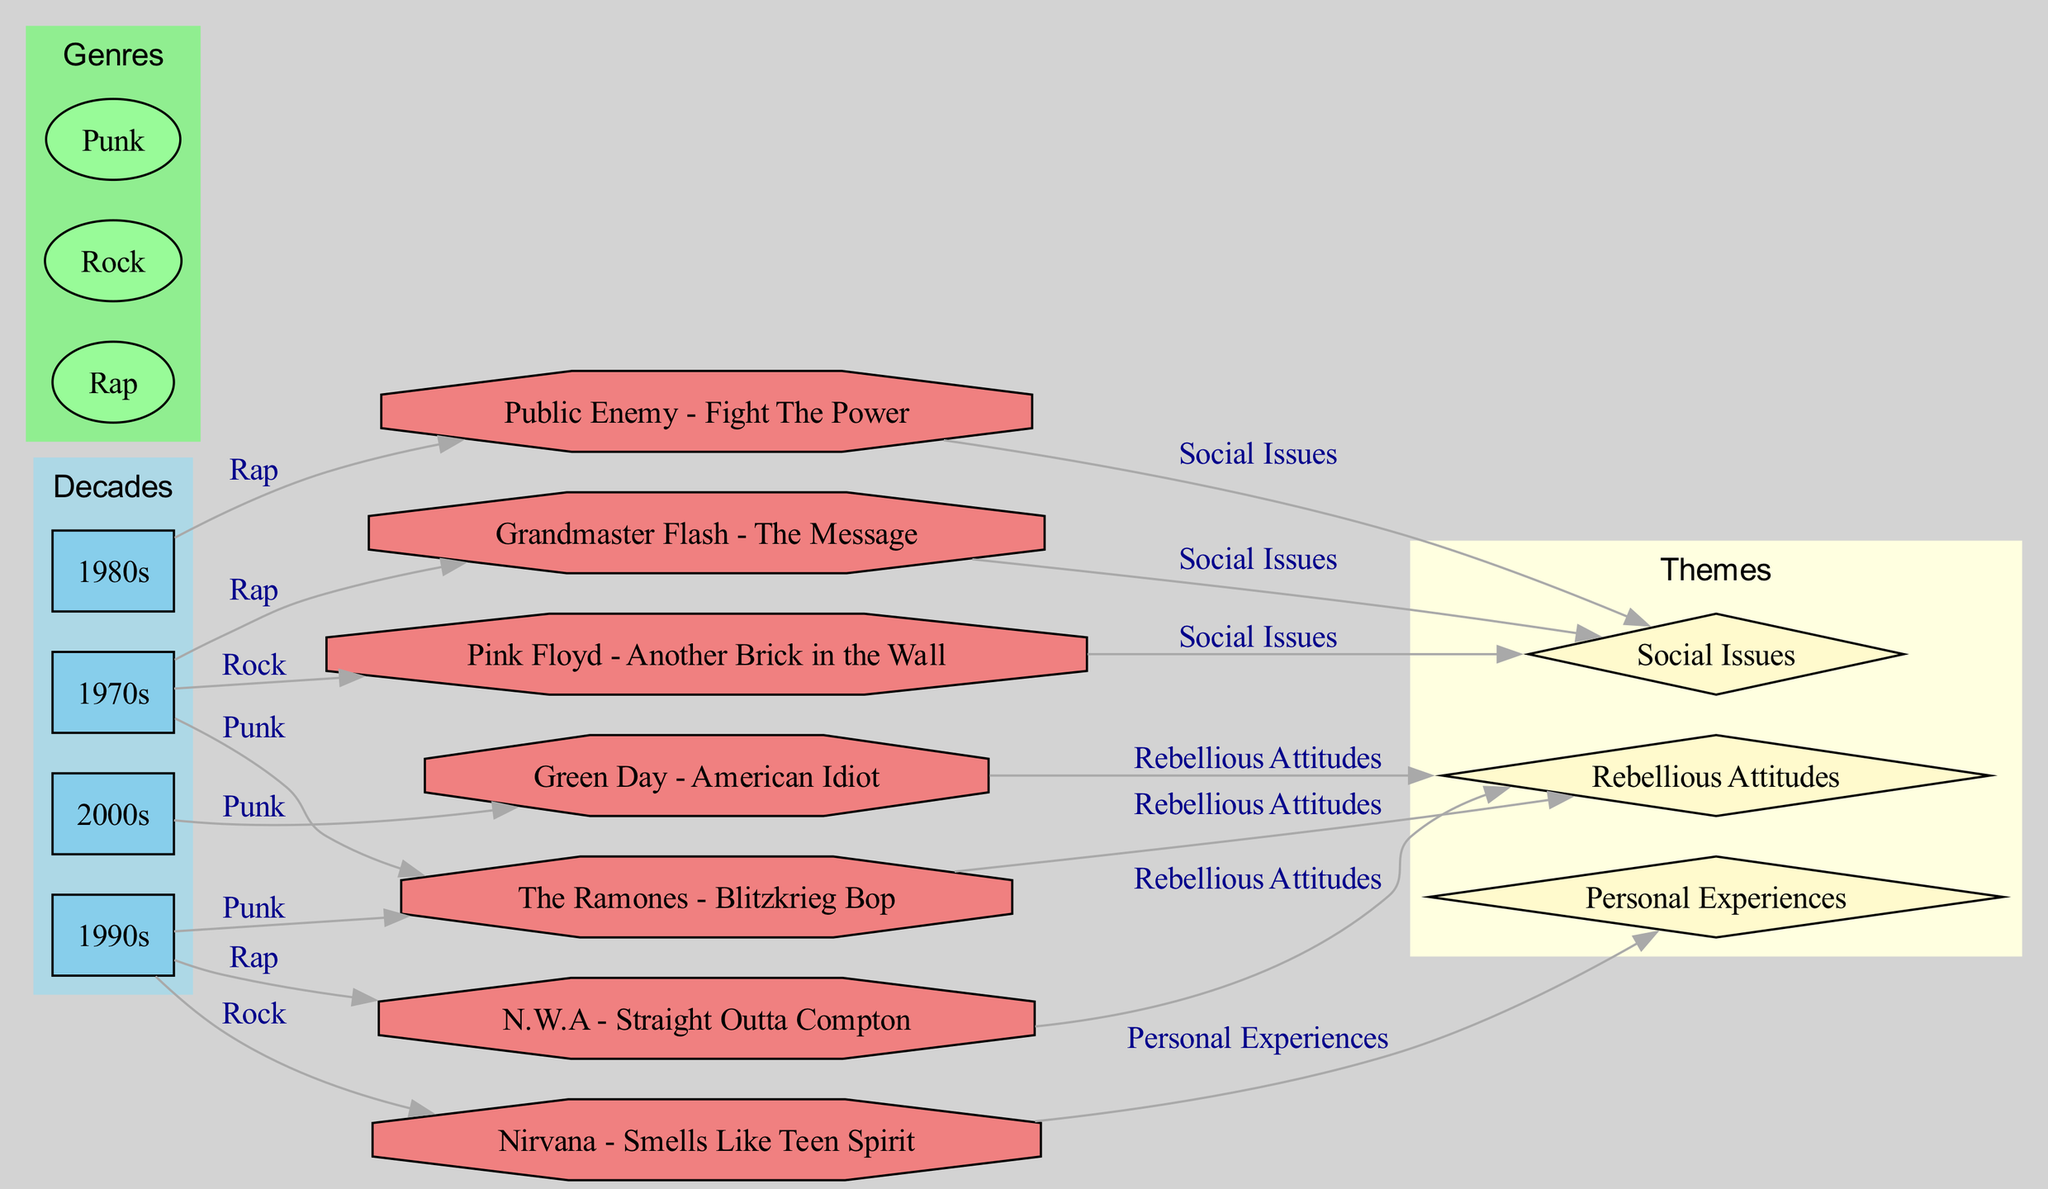What are the three genres represented in the diagram? The diagram includes three genres: Rap, Rock, and Punk. These are specified in the genre subgraph in the diagram.
Answer: Rap, Rock, Punk Which song is linked to social issues from the 1980s? The song linked to social issues from the 1980s is "Public Enemy - Fight The Power." The connection is indicated by the edge from the 1980s node to the Public Enemy node, which is labeled "Social Issues."
Answer: Public Enemy - Fight The Power How many songs are shown in the diagram? There are a total of seven songs represented in the diagram, as listed in the nodes for songs.
Answer: 7 Identify a song from the 1990s associated with personal experiences. The song from the 1990s associated with personal experiences is "Nirvana - Smells Like Teen Spirit," as indicated by the edge connecting Nirvana to the Personal Experiences theme.
Answer: Nirvana - Smells Like Teen Spirit Which decade features "Green Day - American Idiot"? "Green Day - American Idiot" is featured in the 2000s, as shown by the edge connecting the 2000s node to the Green Day node.
Answer: 2000s What theme is represented by both "N.W.A - Straight Outta Compton" and "The Ramones - Blitzkrieg Bop"? Both songs represent the theme of rebellious attitudes, indicated by the edges connecting N.W.A and The Ramones to the Rebellious Attitudes theme.
Answer: Rebellious Attitudes In which decade did Grandmaster Flash's song influence the theme of social issues? Grandmaster Flash's song influenced the theme of social issues in the 1970s, as shown by the edge linking the 1970s node to Grandmaster Flash's node labeled "Social Issues."
Answer: 1970s Name a punk song from the 2000s that expresses rebellious attitudes. The punk song from the 2000s expressing rebellious attitudes is "Green Day - American Idiot," connected to the Rebellious Attitudes theme.
Answer: Green Day - American Idiot 